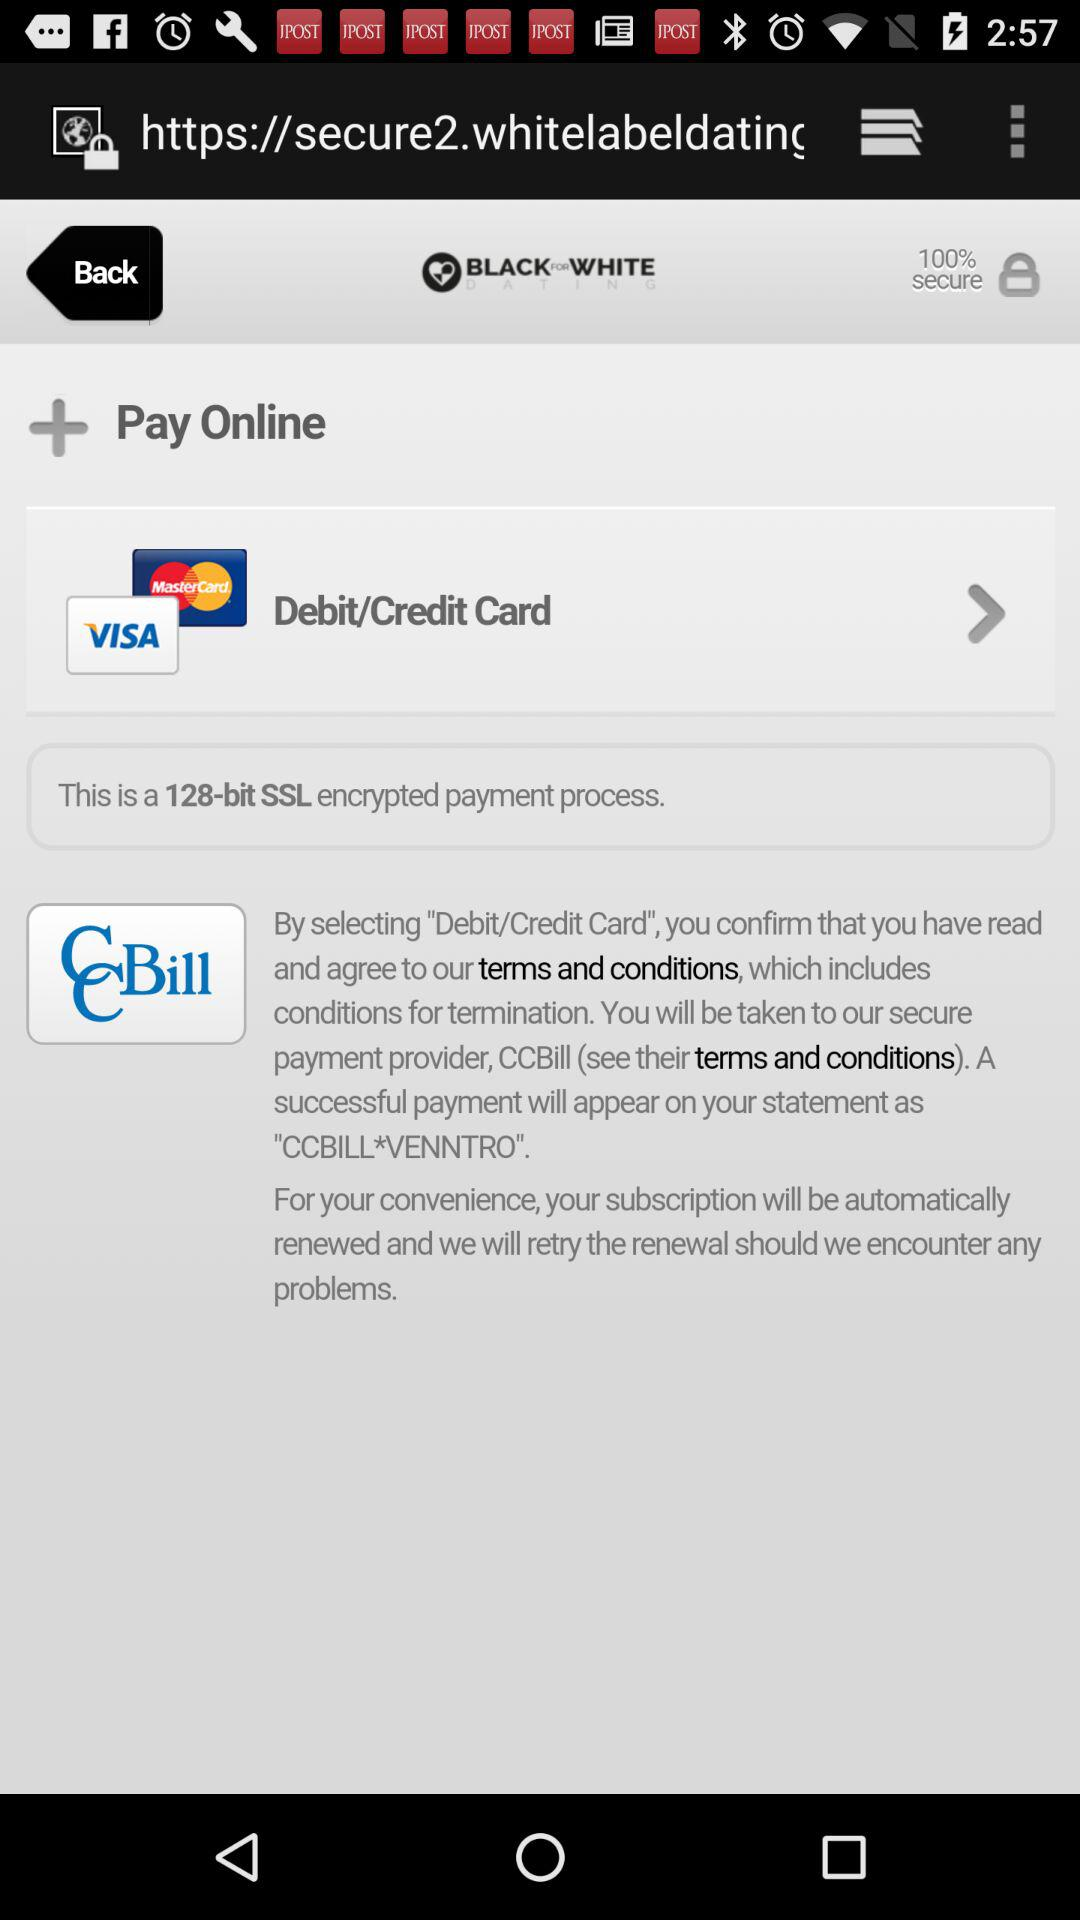Which date is selected? The selected date is February 13, 1989. 